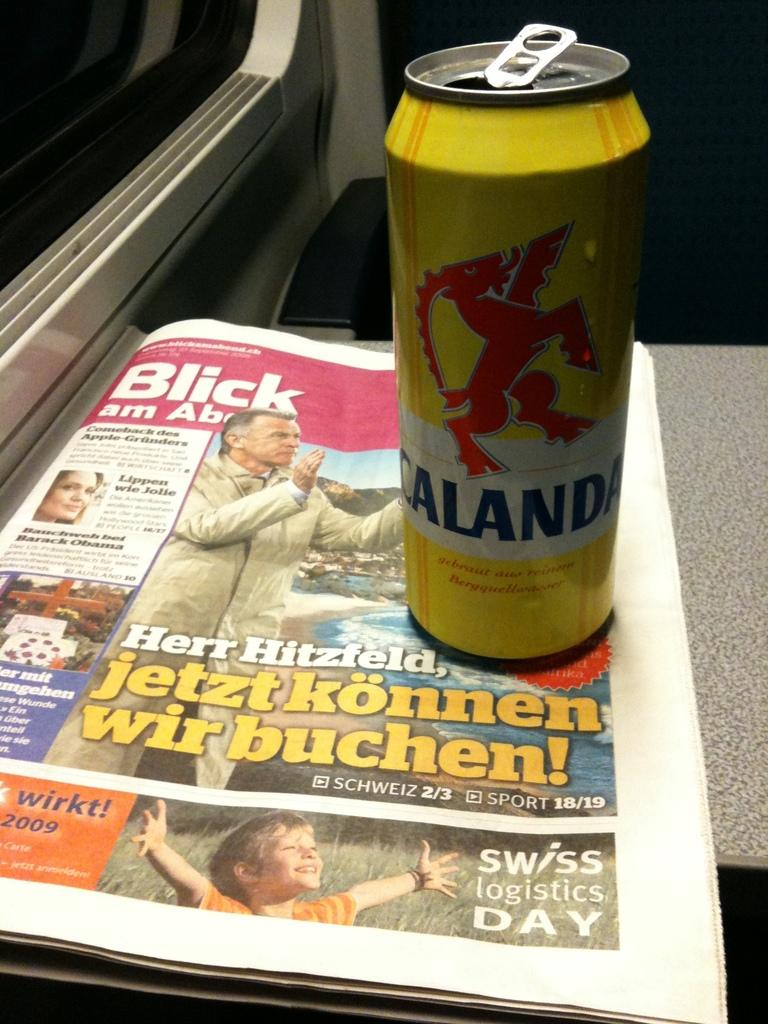<image>
Provide a brief description of the given image. A can of Calanda drink sits on top of a newspaper that advertises Swiss Logistics Day. 